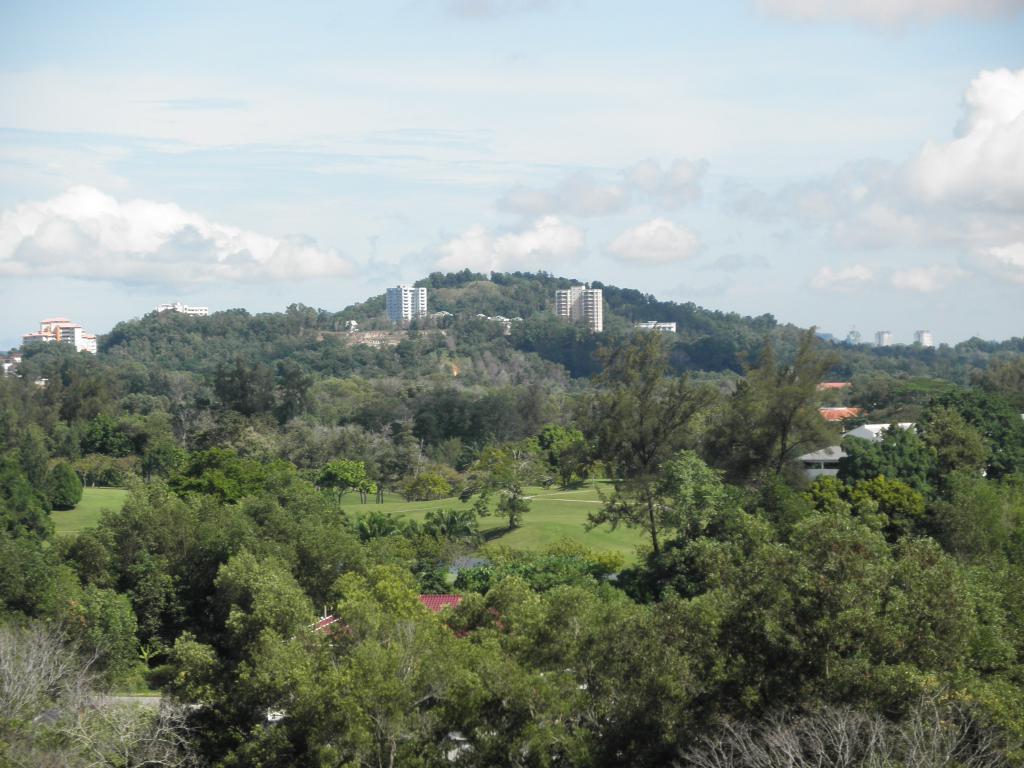In one or two sentences, can you explain what this image depicts? In this image we can see a group of trees, grass, some houses, buildings and the sky which looks cloudy. 